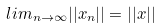<formula> <loc_0><loc_0><loc_500><loc_500>l i m _ { n \rightarrow \infty } | | x _ { n } | | = | | x | |</formula> 